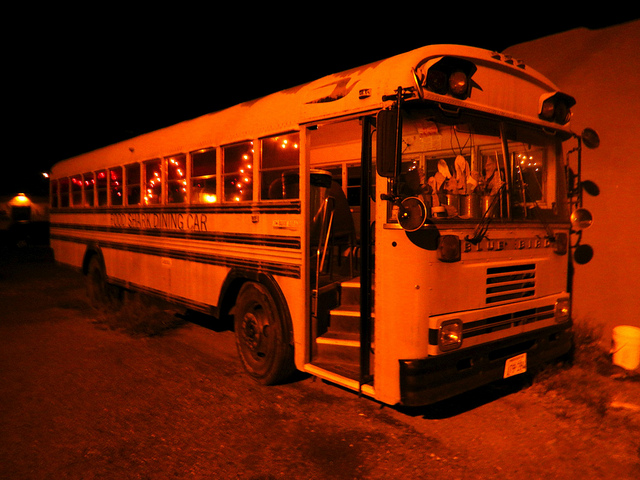Identify the text contained in this image. DINNING CAR 